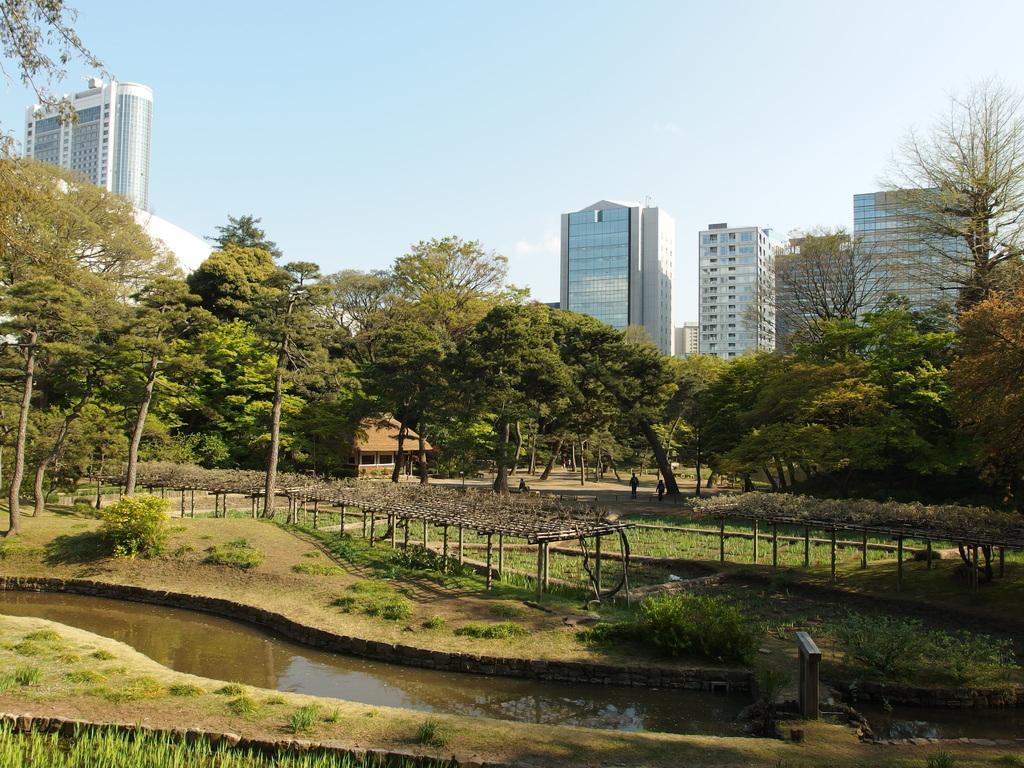Describe this image in one or two sentences. In this image I can see trees, water, plants and the grass. In the background I can see buildings and the sky. 